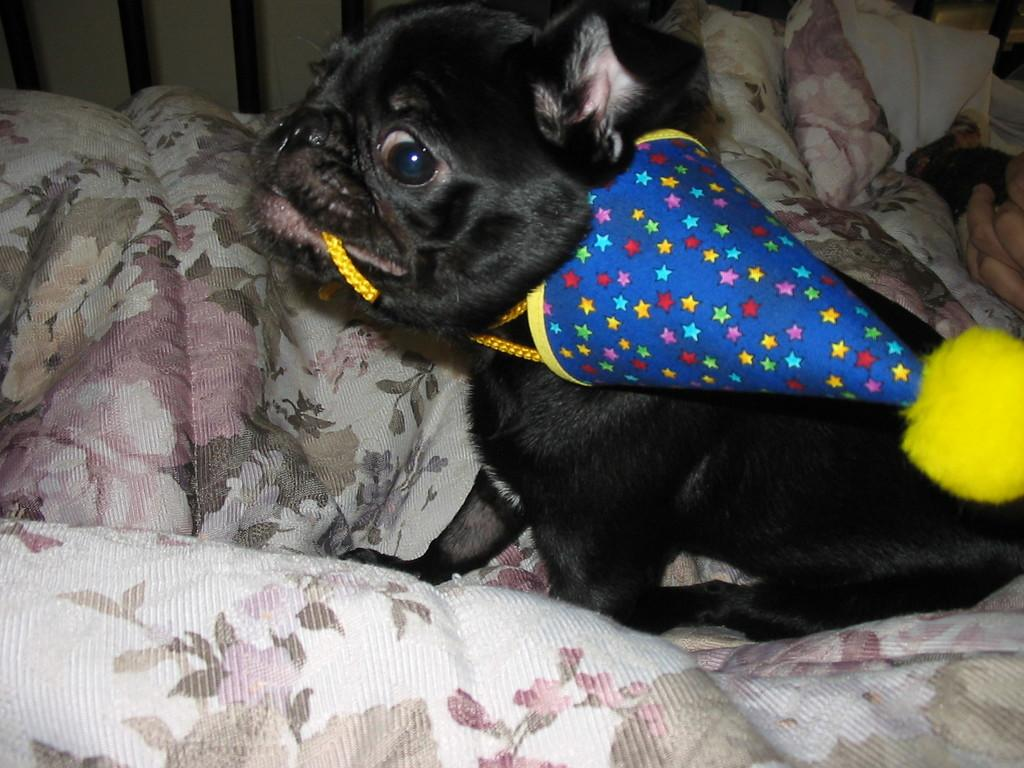What type of animal is in the image? There is a black dog in the image. Where is the dog sitting? The dog is sitting on a blanket. What is the dog wearing? The dog is wearing a party cap. How does the dog use the hammer in the image? There is no hammer present in the image. 